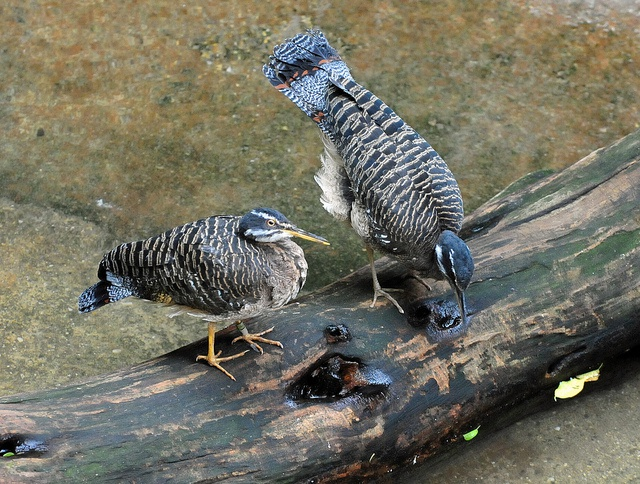Describe the objects in this image and their specific colors. I can see bird in gray, black, darkgray, and lightgray tones and bird in gray, black, darkgray, and lightgray tones in this image. 